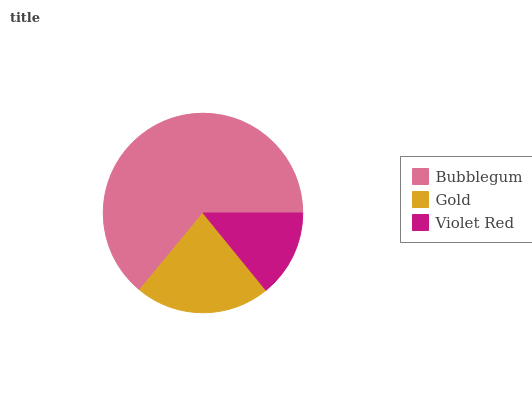Is Violet Red the minimum?
Answer yes or no. Yes. Is Bubblegum the maximum?
Answer yes or no. Yes. Is Gold the minimum?
Answer yes or no. No. Is Gold the maximum?
Answer yes or no. No. Is Bubblegum greater than Gold?
Answer yes or no. Yes. Is Gold less than Bubblegum?
Answer yes or no. Yes. Is Gold greater than Bubblegum?
Answer yes or no. No. Is Bubblegum less than Gold?
Answer yes or no. No. Is Gold the high median?
Answer yes or no. Yes. Is Gold the low median?
Answer yes or no. Yes. Is Violet Red the high median?
Answer yes or no. No. Is Bubblegum the low median?
Answer yes or no. No. 